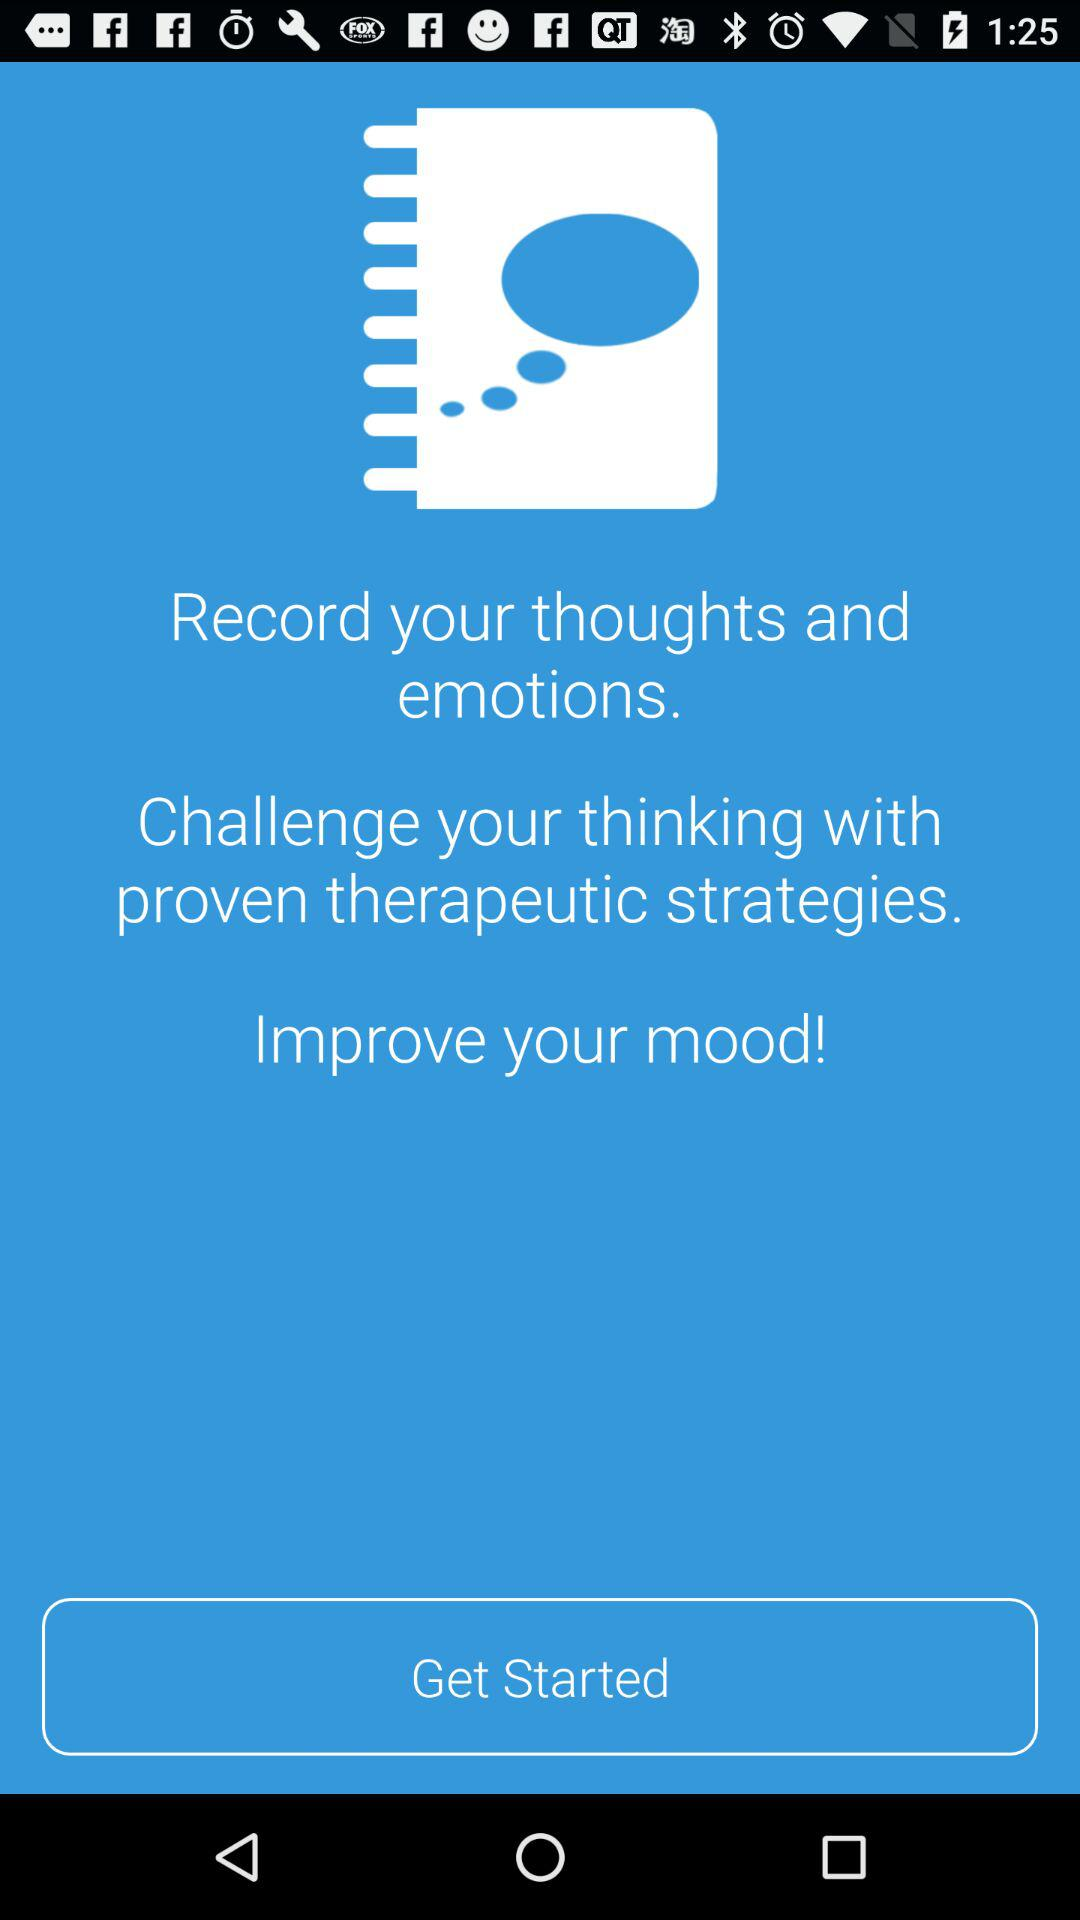What is to be recorded? The information that is to be recorded is your thoughts and emotions. 